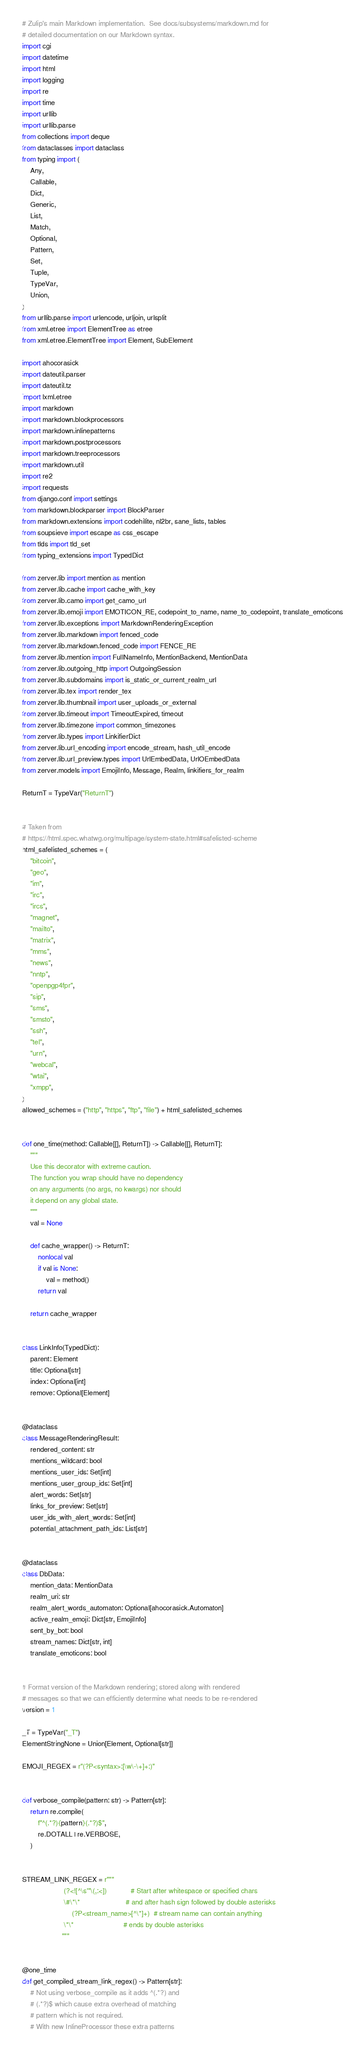<code> <loc_0><loc_0><loc_500><loc_500><_Python_># Zulip's main Markdown implementation.  See docs/subsystems/markdown.md for
# detailed documentation on our Markdown syntax.
import cgi
import datetime
import html
import logging
import re
import time
import urllib
import urllib.parse
from collections import deque
from dataclasses import dataclass
from typing import (
    Any,
    Callable,
    Dict,
    Generic,
    List,
    Match,
    Optional,
    Pattern,
    Set,
    Tuple,
    TypeVar,
    Union,
)
from urllib.parse import urlencode, urljoin, urlsplit
from xml.etree import ElementTree as etree
from xml.etree.ElementTree import Element, SubElement

import ahocorasick
import dateutil.parser
import dateutil.tz
import lxml.etree
import markdown
import markdown.blockprocessors
import markdown.inlinepatterns
import markdown.postprocessors
import markdown.treeprocessors
import markdown.util
import re2
import requests
from django.conf import settings
from markdown.blockparser import BlockParser
from markdown.extensions import codehilite, nl2br, sane_lists, tables
from soupsieve import escape as css_escape
from tlds import tld_set
from typing_extensions import TypedDict

from zerver.lib import mention as mention
from zerver.lib.cache import cache_with_key
from zerver.lib.camo import get_camo_url
from zerver.lib.emoji import EMOTICON_RE, codepoint_to_name, name_to_codepoint, translate_emoticons
from zerver.lib.exceptions import MarkdownRenderingException
from zerver.lib.markdown import fenced_code
from zerver.lib.markdown.fenced_code import FENCE_RE
from zerver.lib.mention import FullNameInfo, MentionBackend, MentionData
from zerver.lib.outgoing_http import OutgoingSession
from zerver.lib.subdomains import is_static_or_current_realm_url
from zerver.lib.tex import render_tex
from zerver.lib.thumbnail import user_uploads_or_external
from zerver.lib.timeout import TimeoutExpired, timeout
from zerver.lib.timezone import common_timezones
from zerver.lib.types import LinkifierDict
from zerver.lib.url_encoding import encode_stream, hash_util_encode
from zerver.lib.url_preview.types import UrlEmbedData, UrlOEmbedData
from zerver.models import EmojiInfo, Message, Realm, linkifiers_for_realm

ReturnT = TypeVar("ReturnT")


# Taken from
# https://html.spec.whatwg.org/multipage/system-state.html#safelisted-scheme
html_safelisted_schemes = (
    "bitcoin",
    "geo",
    "im",
    "irc",
    "ircs",
    "magnet",
    "mailto",
    "matrix",
    "mms",
    "news",
    "nntp",
    "openpgp4fpr",
    "sip",
    "sms",
    "smsto",
    "ssh",
    "tel",
    "urn",
    "webcal",
    "wtai",
    "xmpp",
)
allowed_schemes = ("http", "https", "ftp", "file") + html_safelisted_schemes


def one_time(method: Callable[[], ReturnT]) -> Callable[[], ReturnT]:
    """
    Use this decorator with extreme caution.
    The function you wrap should have no dependency
    on any arguments (no args, no kwargs) nor should
    it depend on any global state.
    """
    val = None

    def cache_wrapper() -> ReturnT:
        nonlocal val
        if val is None:
            val = method()
        return val

    return cache_wrapper


class LinkInfo(TypedDict):
    parent: Element
    title: Optional[str]
    index: Optional[int]
    remove: Optional[Element]


@dataclass
class MessageRenderingResult:
    rendered_content: str
    mentions_wildcard: bool
    mentions_user_ids: Set[int]
    mentions_user_group_ids: Set[int]
    alert_words: Set[str]
    links_for_preview: Set[str]
    user_ids_with_alert_words: Set[int]
    potential_attachment_path_ids: List[str]


@dataclass
class DbData:
    mention_data: MentionData
    realm_uri: str
    realm_alert_words_automaton: Optional[ahocorasick.Automaton]
    active_realm_emoji: Dict[str, EmojiInfo]
    sent_by_bot: bool
    stream_names: Dict[str, int]
    translate_emoticons: bool


# Format version of the Markdown rendering; stored along with rendered
# messages so that we can efficiently determine what needs to be re-rendered
version = 1

_T = TypeVar("_T")
ElementStringNone = Union[Element, Optional[str]]

EMOJI_REGEX = r"(?P<syntax>:[\w\-\+]+:)"


def verbose_compile(pattern: str) -> Pattern[str]:
    return re.compile(
        f"^(.*?){pattern}(.*?)$",
        re.DOTALL | re.VERBOSE,
    )


STREAM_LINK_REGEX = r"""
                     (?<![^\s'"\(,:<])            # Start after whitespace or specified chars
                     \#\*\*                       # and after hash sign followed by double asterisks
                         (?P<stream_name>[^\*]+)  # stream name can contain anything
                     \*\*                         # ends by double asterisks
                    """


@one_time
def get_compiled_stream_link_regex() -> Pattern[str]:
    # Not using verbose_compile as it adds ^(.*?) and
    # (.*?)$ which cause extra overhead of matching
    # pattern which is not required.
    # With new InlineProcessor these extra patterns</code> 